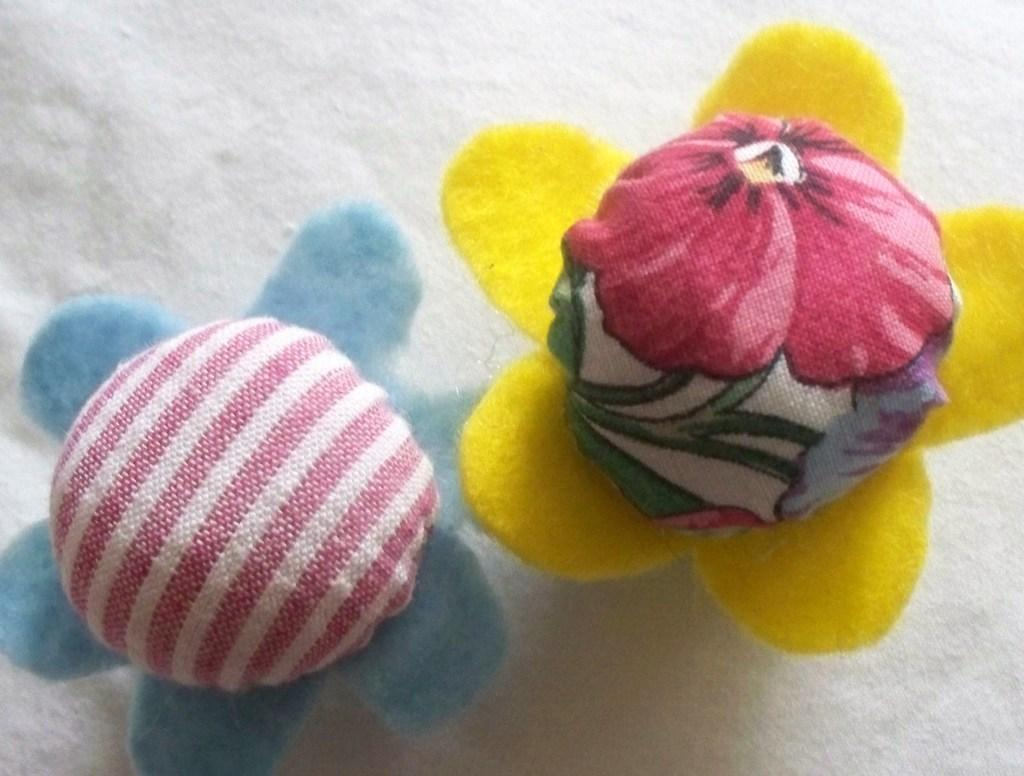What type of objects can be seen in the image? There are cushions in the image. Can you describe the texture or material of the cushions? The facts provided do not specify the texture or material of the cushions. Are the cushions arranged in a specific pattern or design? The facts provided do not specify any arrangement or design of the cushions. What type of breakfast is being served by the giants in the image? There are no giants or breakfast present in the image; it only features cushions. 